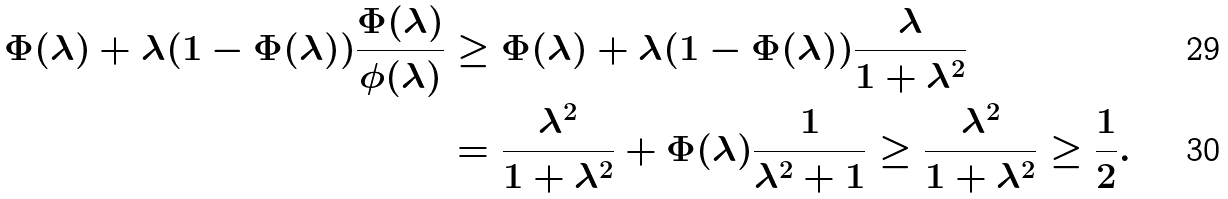<formula> <loc_0><loc_0><loc_500><loc_500>\Phi ( \lambda ) + \lambda ( 1 - \Phi ( \lambda ) ) \frac { \Phi ( \lambda ) } { \phi ( \lambda ) } & \geq \Phi ( \lambda ) + \lambda ( 1 - \Phi ( \lambda ) ) \frac { \lambda } { 1 + \lambda ^ { 2 } } \\ & = \frac { \lambda ^ { 2 } } { 1 + \lambda ^ { 2 } } + \Phi ( \lambda ) \frac { 1 } { \lambda ^ { 2 } + 1 } \geq \frac { \lambda ^ { 2 } } { 1 + \lambda ^ { 2 } } \geq \frac { 1 } { 2 } .</formula> 